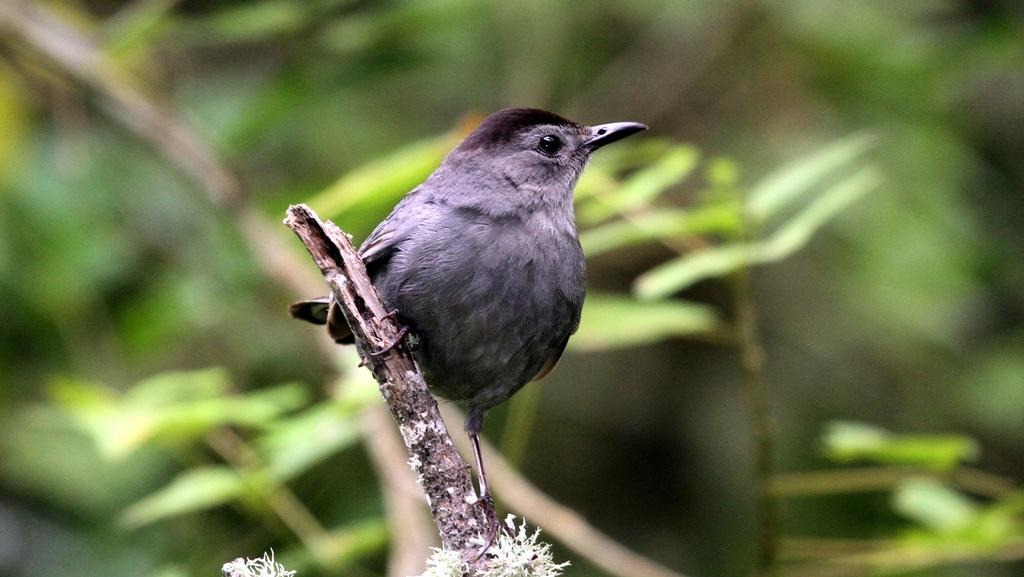What type of animal can be seen in the image? There is a bird in the image. Where is the bird located? The bird is on a stem in the image. Can you describe the background of the image? The background of the image is blurred. How does the bird's beginner status affect its performance in the competition? There is no competition present in the image, and the bird's status as a beginner cannot be determined from the image. 